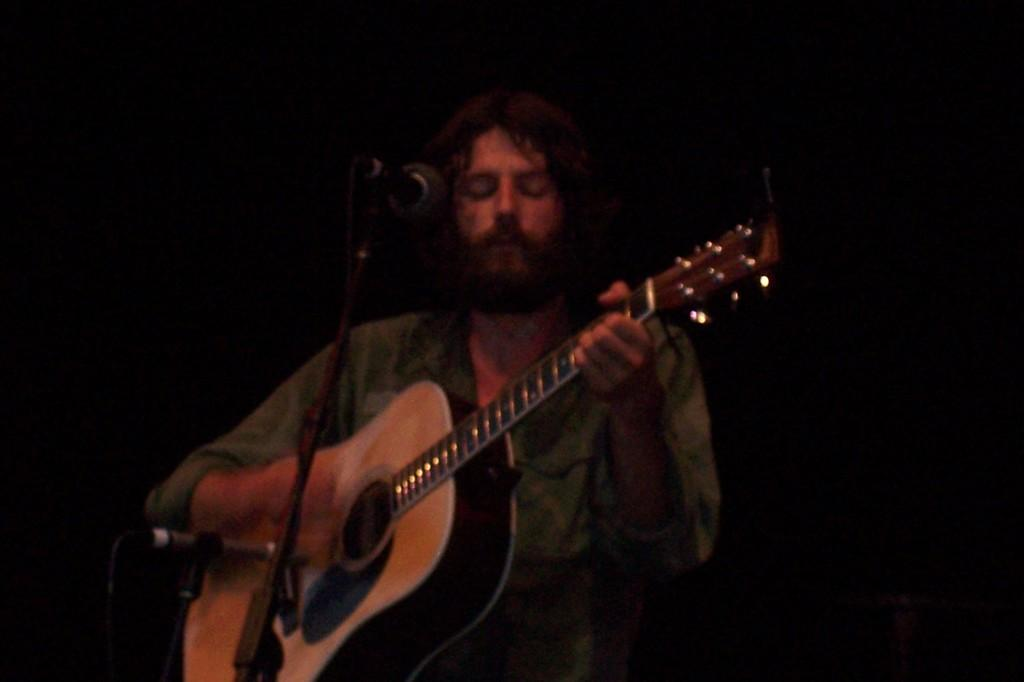What is the main subject of the image? There is a person in the image. What is the person doing in the image? The person is playing a guitar. What other object related to music can be seen in the image? There is a microphone with a stand in the image. What time of day is the discussion taking place in the image? There is no discussion taking place in the image, and therefore no time of day can be determined. 